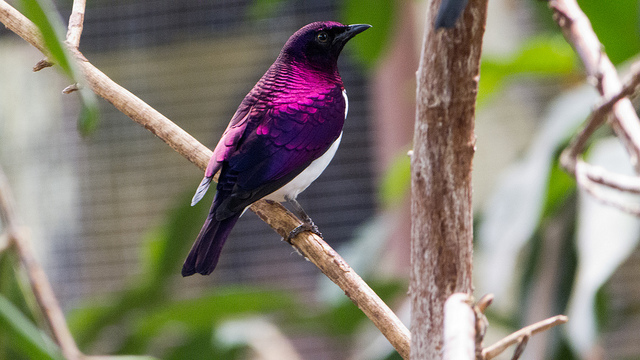Can you provide some information about the habitat of this bird? The Amethyst Starling is typically found in the woodlands, forest edges, and savannahs of Sub-Saharan Africa. These birds thrive in areas where there is a mix of open spaces and dense vegetation, which provides them with ample foraging opportunities and nesting sites. 